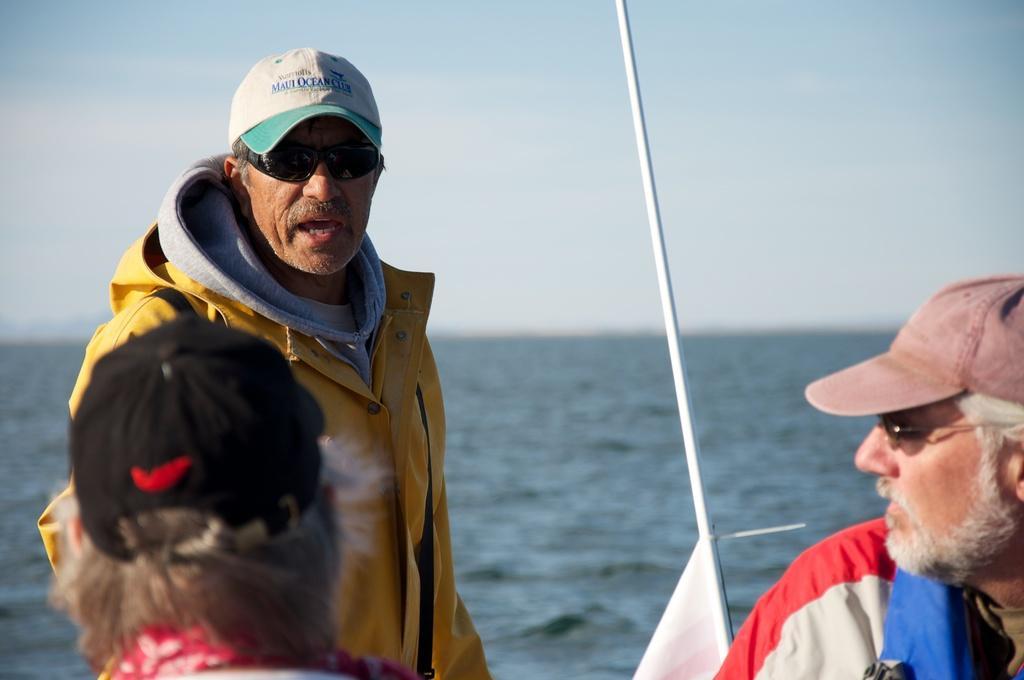Please provide a concise description of this image. Here a man is there, he wore a yellow color coat. In the right side there is another man, he wore a cap, spectacles. This is water in the middle of an image. 